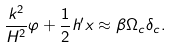Convert formula to latex. <formula><loc_0><loc_0><loc_500><loc_500>\frac { k ^ { 2 } } { H ^ { 2 } } \varphi + \frac { 1 } { 2 } h ^ { \prime } x \approx \beta \Omega _ { c } \delta _ { c } .</formula> 